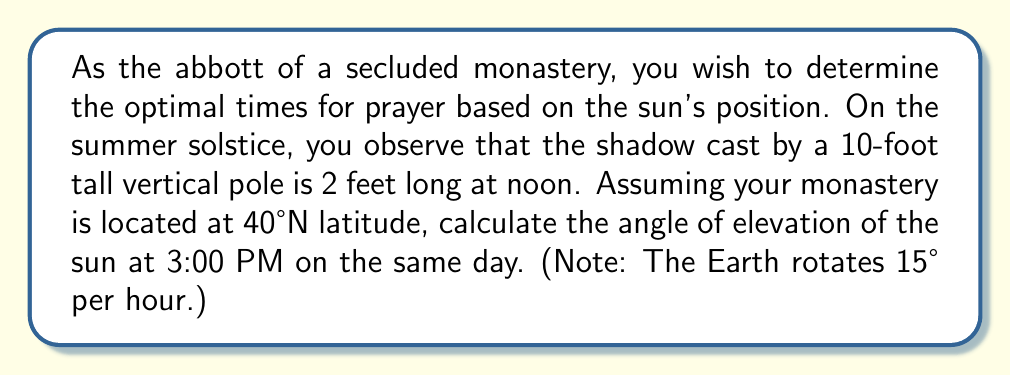Show me your answer to this math problem. Let's approach this problem step-by-step:

1) First, we need to find the angle of elevation at noon:
   Using the tangent function, we can calculate this angle:
   $$ \tan(\theta) = \frac{\text{opposite}}{\text{adjacent}} = \frac{10}{2} = 5 $$
   $$ \theta = \arctan(5) \approx 78.69° $$

2) Now, we need to consider the Earth's rotation:
   - From noon to 3:00 PM, 3 hours have passed
   - The Earth rotates 15° per hour, so in 3 hours it rotates 45°

3) However, we can't simply subtract 45° from 78.69°. We need to consider the latitude and use spherical trigonometry.

4) The formula for the sun's elevation angle $h$ at any time is:
   $$ \sin(h) = \sin(\delta)\sin(\phi) + \cos(\delta)\cos(\phi)\cos(H) $$
   Where:
   $\delta$ is the sun's declination (23.45° on the summer solstice)
   $\phi$ is the latitude (40°N in this case)
   $H$ is the hour angle (45° at 3:00 PM)

5) Plugging in the values:
   $$ \sin(h) = \sin(23.45°)\sin(40°) + \cos(23.45°)\cos(40°)\cos(45°) $$

6) Calculating:
   $$ \sin(h) \approx 0.7850 $$

7) Taking the inverse sine:
   $$ h = \arcsin(0.7850) \approx 51.73° $$

[asy]
import geometry;

size(200);
draw((-3,0)--(3,0), arrow=Arrow(TeXHead));
draw((0,-1)--(0,3), arrow=Arrow(TeXHead));
draw((-2,0)--(2,tan(51.73*pi/180)*2), red);
label("Sun's rays", (2,tan(51.73*pi/180)*2), E);
draw((0,0)--(2,0), blue);
draw((2,0)--(2,tan(51.73*pi/180)*2), blue);
label("51.73°", (0.5,0.5), NE);
[/asy]
Answer: The angle of elevation of the sun at 3:00 PM on the summer solstice at 40°N latitude is approximately 51.73°. 